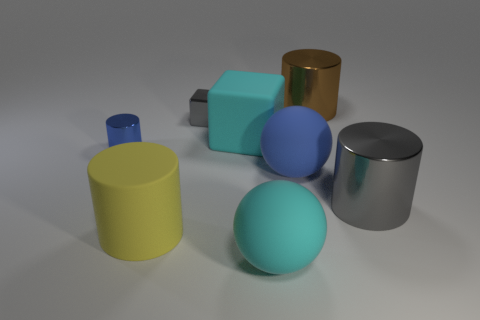Is the number of gray cubes that are right of the small cylinder greater than the number of small matte objects?
Keep it short and to the point. Yes. The big matte block has what color?
Your response must be concise. Cyan. What is the shape of the big metal object in front of the gray thing that is behind the cylinder that is to the left of the large yellow thing?
Your response must be concise. Cylinder. There is a cylinder that is both behind the big matte cylinder and on the left side of the cyan ball; what is its material?
Your response must be concise. Metal. There is a cyan rubber thing that is behind the rubber sphere in front of the big gray object; what shape is it?
Give a very brief answer. Cube. Is there anything else of the same color as the rubber cylinder?
Provide a short and direct response. No. Do the gray cylinder and the gray object behind the blue metallic object have the same size?
Your answer should be compact. No. How many tiny things are cyan things or blue cylinders?
Give a very brief answer. 1. Is the number of large brown cylinders greater than the number of big metallic cylinders?
Provide a short and direct response. No. There is a gray thing in front of the blue object to the right of the yellow thing; how many cyan rubber objects are on the right side of it?
Keep it short and to the point. 0. 